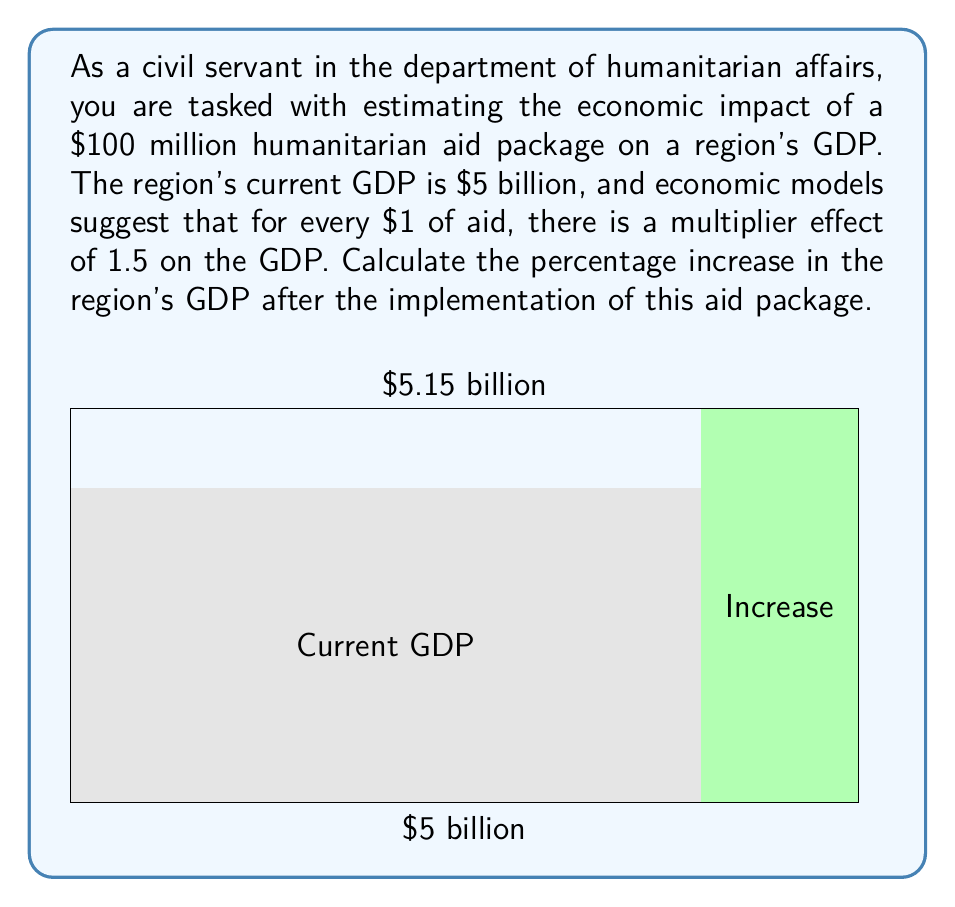Solve this math problem. Let's approach this problem step-by-step:

1) First, we need to calculate the total impact of the aid package on the GDP:
   - The aid package is $100 million = $0.1 billion
   - The multiplier effect is 1.5
   - Total impact = Aid × Multiplier
   $$\text{Total Impact} = \$0.1 \text{ billion} \times 1.5 = \$0.15 \text{ billion}$$

2) Now, we can calculate the new GDP:
   - Current GDP = $5 billion
   - New GDP = Current GDP + Total Impact
   $$\text{New GDP} = \$5 \text{ billion} + \$0.15 \text{ billion} = \$5.15 \text{ billion}$$

3) To calculate the percentage increase, we use the formula:
   $$\text{Percentage Increase} = \frac{\text{Increase}}{\text{Original}} \times 100\%$$

   Where:
   - Increase = New GDP - Original GDP = $5.15 billion - $5 billion = $0.15 billion
   - Original = $5 billion

4) Plugging these values into the formula:
   $$\text{Percentage Increase} = \frac{\$0.15 \text{ billion}}{\$5 \text{ billion}} \times 100\% = 0.03 \times 100\% = 3\%$$

Therefore, the humanitarian aid package is estimated to increase the region's GDP by 3%.
Answer: 3% 